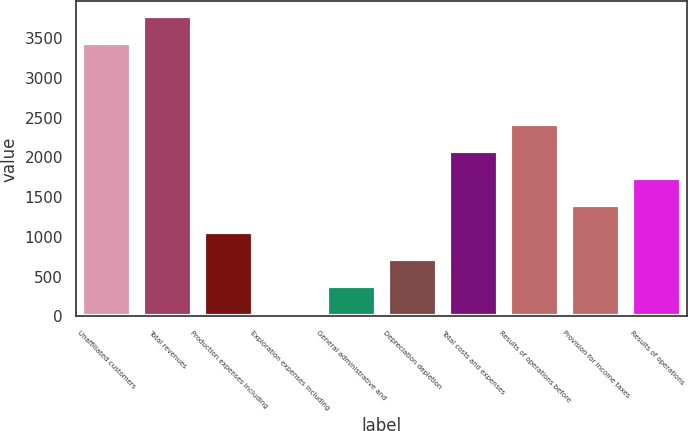<chart> <loc_0><loc_0><loc_500><loc_500><bar_chart><fcel>Unaffiliated customers<fcel>Total revenues<fcel>Production expenses including<fcel>Exploration expenses including<fcel>General administrative and<fcel>Depreciation depletion<fcel>Total costs and expenses<fcel>Results of operations before<fcel>Provision for income taxes<fcel>Results of operations<nl><fcel>3435<fcel>3774<fcel>1062<fcel>45<fcel>384<fcel>723<fcel>2079<fcel>2418<fcel>1401<fcel>1740<nl></chart> 